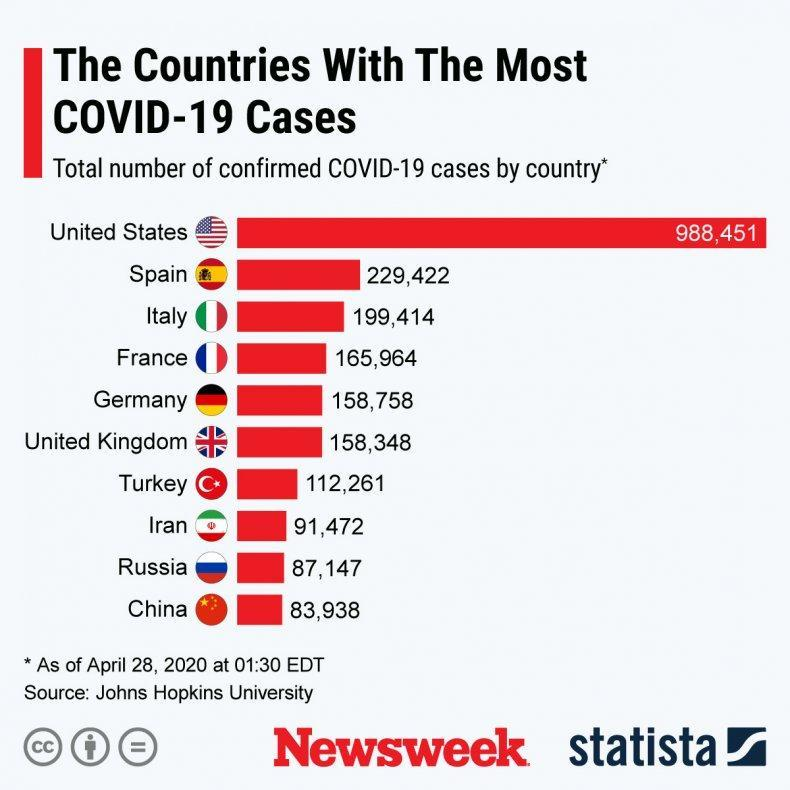Which country has the least number of confirmed Covid-19 cases as of April 28, 2020?
Answer the question with a short phrase. China Which country has the second least number of confirmed Covid-19 cases as of April 28, 2020? Russia Which country has the second highest number of confirmed Covid-19 cases as of April 28, 2020? Spain What is the total number of confirmed Covid-19 cases  in Germany as of April 28, 2020? 158,758 Which country has the highest number of confirmed Covid-19 cases as of April 28, 2020? United States Which country has the third highest number of confirmed Covid-19 cases as of April 28, 2020? Italy What is the total number of confirmed Covid-19 cases in Iran as of April 28, 2020? 91,472 What is the total number of confirmed Covid-19 cases in Spain as of April 28, 2020? 229,422 